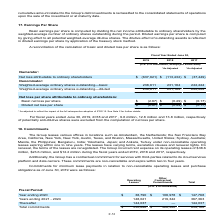From Atlassian Plc's financial document, What is the number of potentially anti-dilutive shares that were excluded for fiscal years ended June 30, 2017, 2018 and 2019 respectively?  The document contains multiple relevant values: 13.8 million, 12.8 million, 9.6 million. From the document: "fiscal years ended June 30, 2019, 2018 and 2017 , 9.6 million, 12.8 million and 13.8 million, respectively 19, 2018 and 2017 , 9.6 million, 12.8 milli..." Also, How is basic earnings per share computed? Dividing the net income attributable to ordinary shareholders by the weighted-average number of ordinary shares outstanding during the period. The document states: "Basic earnings per share is computed by dividing the net income attributable to ordinary shareholders by the weighted-average number of ordinary share..." Also, What is the  Net loss attributable to ordinary shareholders for fiscal year 2019? According to the financial document, $(637,621) (in thousands). The relevant text states: "Net loss attributable to ordinary shareholders $ (637,621) $ (113,432) $ (37,449)..." Also, can you calculate: In fiscal year ended June 30, 2019, what is the difference in the weighted-average ordinary shares outstanding between the basic and the diluted? I cannot find a specific answer to this question in the financial document. Also, can you calculate: What is the average basic net loss per share for fiscal years ended June 30, 2017, 2018 and 2019? To answer this question, I need to perform calculations using the financial data. The calculation is: -(2.67+0.49+0.17)/3, which equals -1.11. This is based on the information: "Basic net loss per share $ (2.67) $ (0.49) $ (0.17) Basic net loss per share $ (2.67) $ (0.49) $ (0.17) Basic net loss per share $ (2.67) $ (0.49) $ (0.17)..." The key data points involved are: 0.17, 0.49, 2.67. Also, can you calculate: What is the percentage change for the weighted-average ordinary basic shares outstanding between fiscal years ended June 30, 2018 and 2019? To answer this question, I need to perform calculations using the financial data. The calculation is: (238,611-231,184)/231,184, which equals 3.21 (percentage). This is based on the information: "average ordinary shares outstanding—basic 238,611 231,184 222,224 eighted-average ordinary shares outstanding—basic 238,611 231,184 222,224..." The key data points involved are: 231,184, 238,611. 